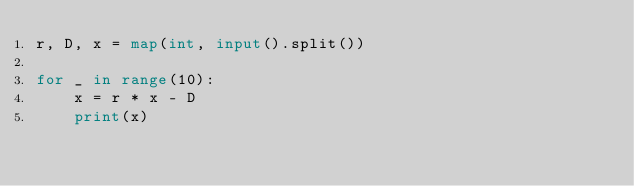Convert code to text. <code><loc_0><loc_0><loc_500><loc_500><_Python_>r, D, x = map(int, input().split())

for _ in range(10):
    x = r * x - D
    print(x)</code> 